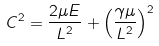Convert formula to latex. <formula><loc_0><loc_0><loc_500><loc_500>C ^ { 2 } = \frac { 2 \mu E } { L ^ { 2 } } + \left ( \frac { \gamma \mu } { L ^ { 2 } } \right ) ^ { 2 }</formula> 